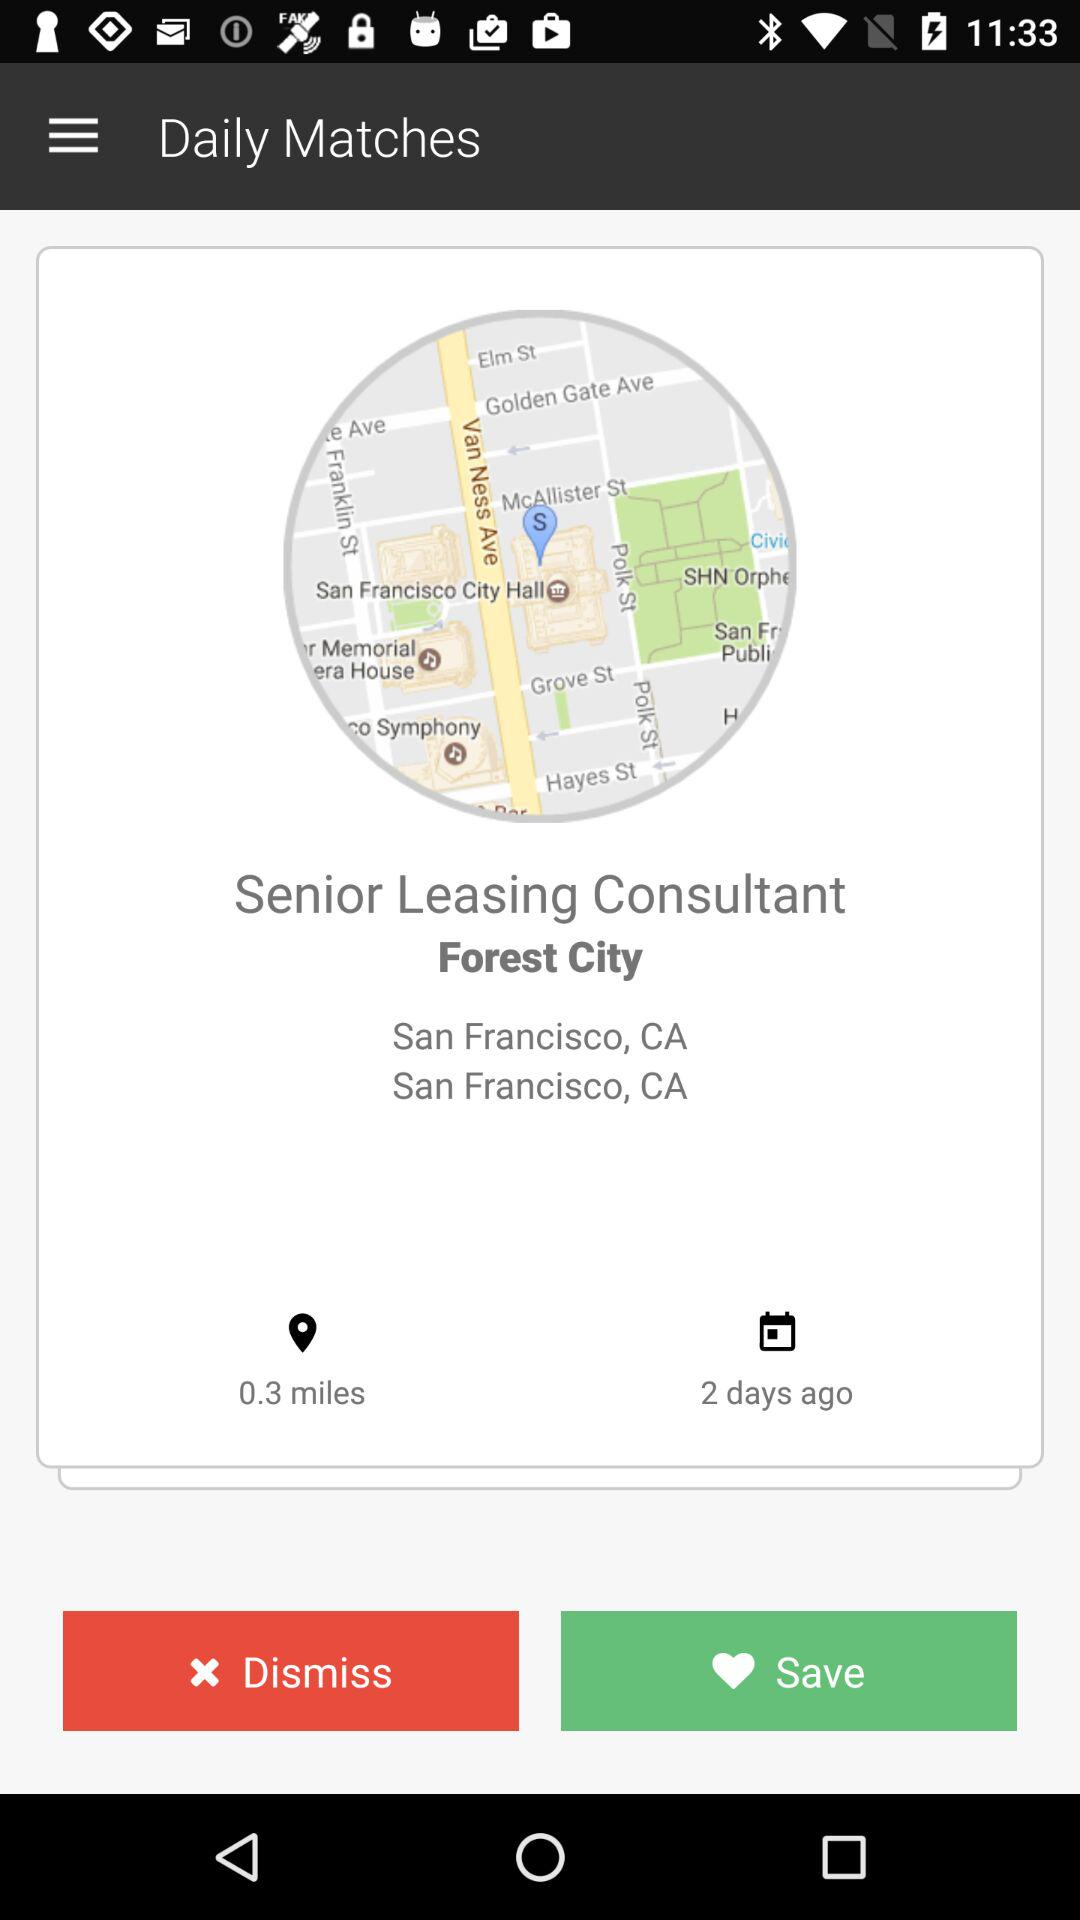What is the searching location?
When the provided information is insufficient, respond with <no answer>. <no answer> 